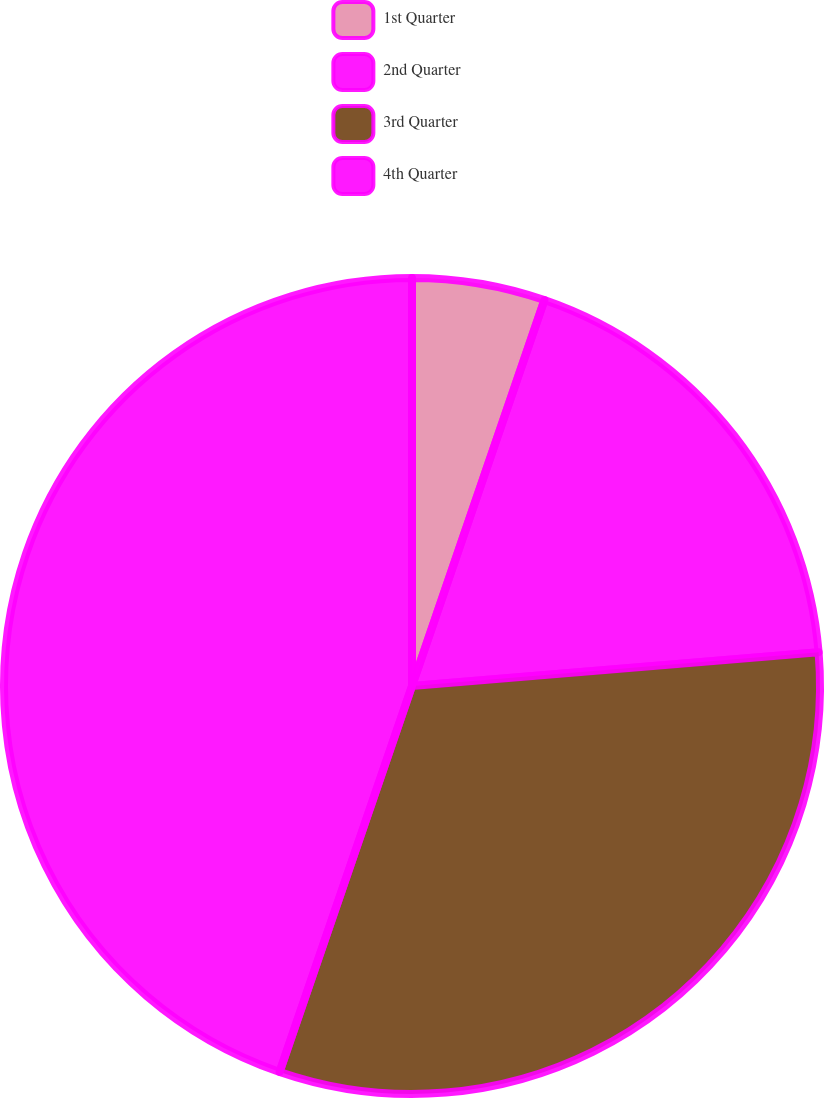<chart> <loc_0><loc_0><loc_500><loc_500><pie_chart><fcel>1st Quarter<fcel>2nd Quarter<fcel>3rd Quarter<fcel>4th Quarter<nl><fcel>5.26%<fcel>18.42%<fcel>31.58%<fcel>44.74%<nl></chart> 